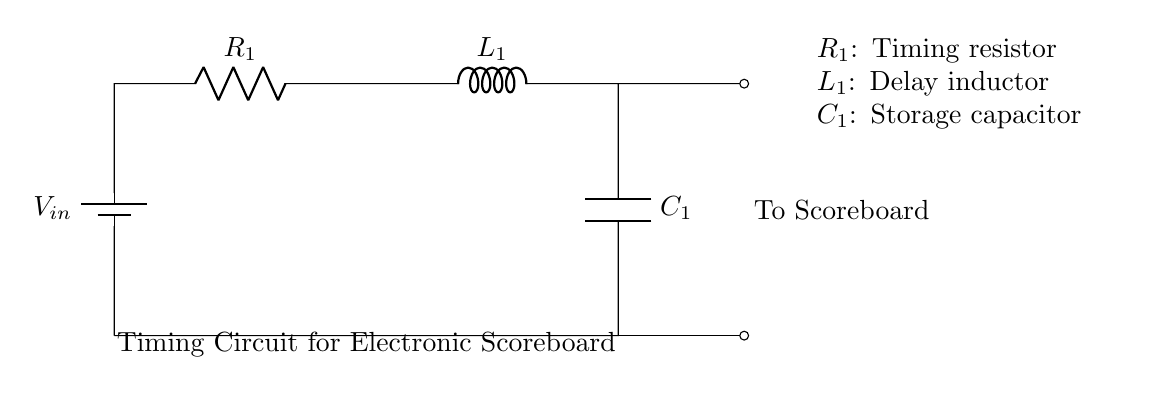What is the voltage source in this circuit? The voltage source in this circuit is labeled as "V_in," indicating the input voltage.
Answer: V_in What components are present in this circuit? The components include a resistor (R_1), an inductor (L_1), and a capacitor (C_1), which are connected in series.
Answer: R_1, L_1, C_1 What does the resistor R_1 represent in this timing circuit? The resistor R_1 is labeled as the "Timing resistor," indicating its role in setting the timing characteristics of the circuit.
Answer: Timing resistor How do the inductor and capacitor interact in this circuit? The inductor L_1 is used for delay, and the capacitor C_1 is used for storage, creating a timing effect due to their reactive properties.
Answer: Delay and storage What is the primary purpose of this circuit? The primary purpose of the circuit is to function as a timing circuit for an electronic scoreboard by managing delays and timing signals.
Answer: Timing circuit 